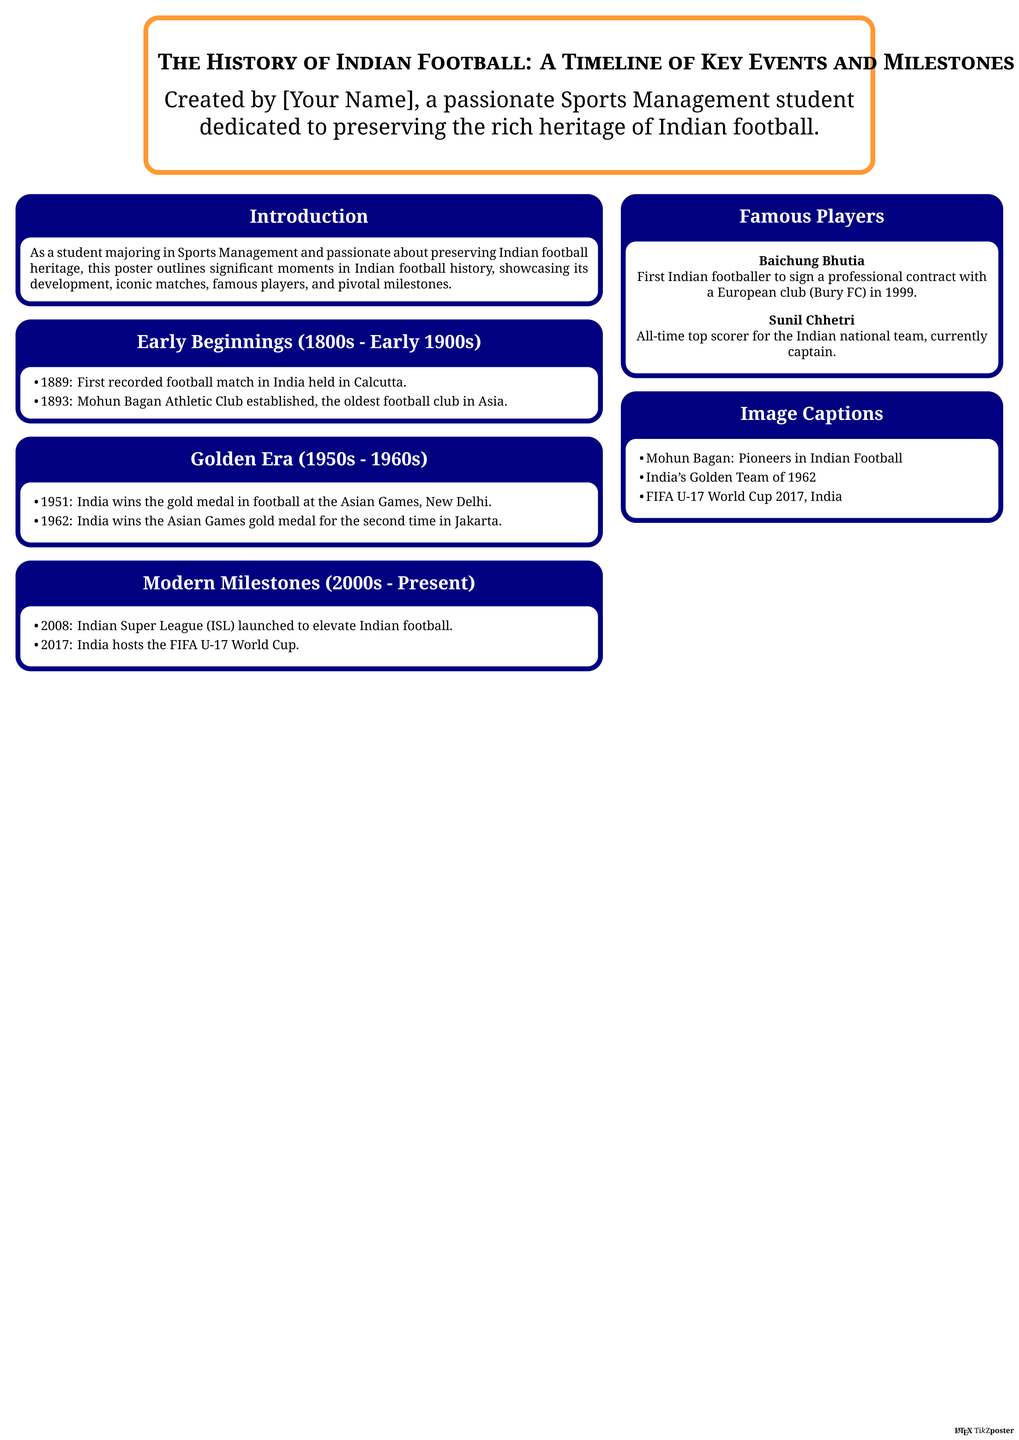What was the first recorded football match in India? The first recorded football match took place in 1889, as mentioned in the Early Beginnings section.
Answer: 1889 Who is the first Indian footballer to sign a professional contract with a European club? The document mentions Baichung Bhutia in the Famous Players section as the first Indian footballer to sign a professional contract with Bury FC.
Answer: Baichung Bhutia In what year did India win the gold medal at the Asian Games for the first time? The Golden Era section notes that India won the gold medal in football in 1951 at the Asian Games.
Answer: 1951 What is the significance of the year 2008 in Indian football? The Modern Milestones section highlights the launch of the Indian Super League (ISL) in 2008.
Answer: Indian Super League (ISL) Which iconic team is referred to in the document as "India's Golden Team"? The document captures the essence of the team that won the Asian Games in 1962.
Answer: India's Golden Team of 1962 How many times did India win the Asian Games gold medal in football during the 1960s? The document states that India secured gold medals in both 1951 and 1962, indicating two wins in the 1960s.
Answer: 2 times What major event did India host in 2017? In the Modern Milestones section, it is specified that India hosted the FIFA U-17 World Cup in 2017.
Answer: FIFA U-17 World Cup What color is used for the header in the poster? The document uses the color Indian green for the header, as specified in the color definitions.
Answer: Indian green 